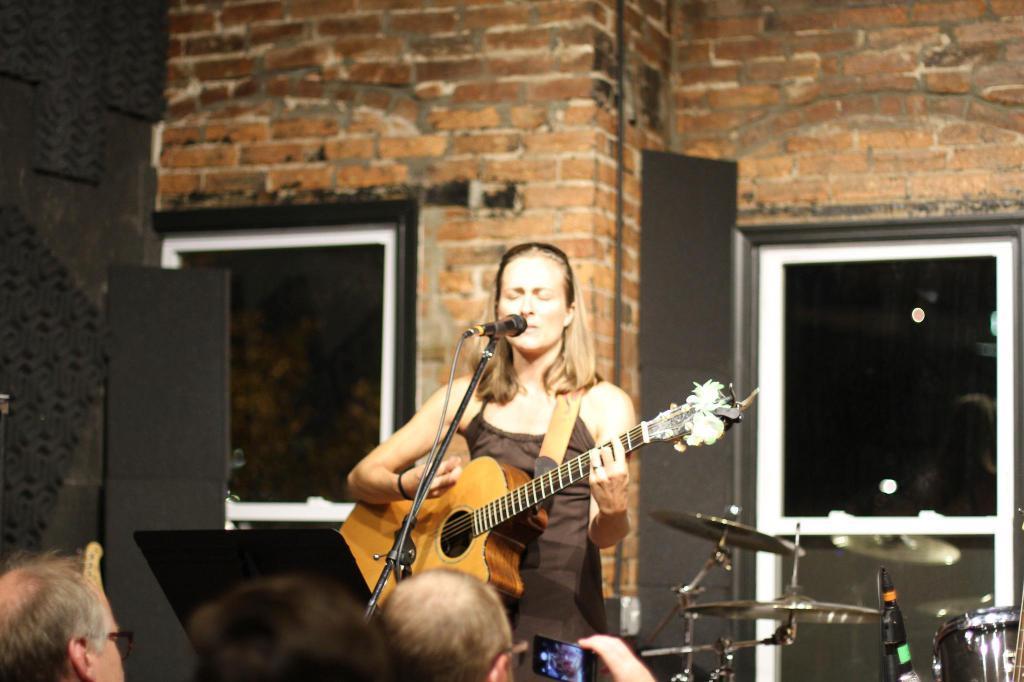Can you describe this image briefly? In this picture there is a person standing and holding guitar. There is a microphone with stand. There are few persons. This person holding mobile. On the background we can see wall,window. 